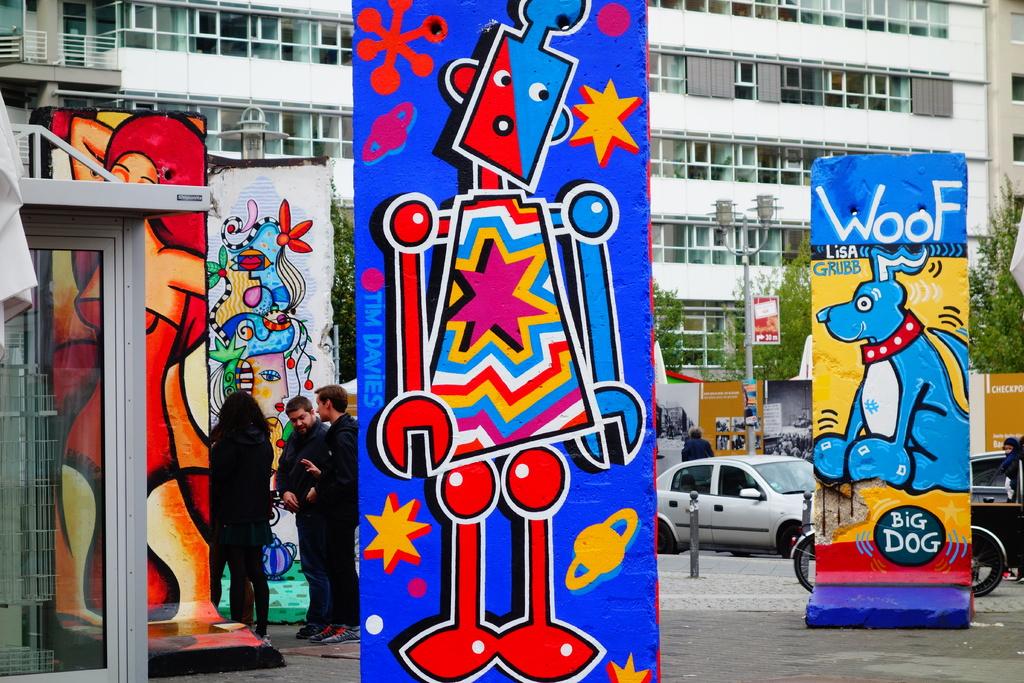Who drew the big dog?
Keep it short and to the point. Lisa grubb. 